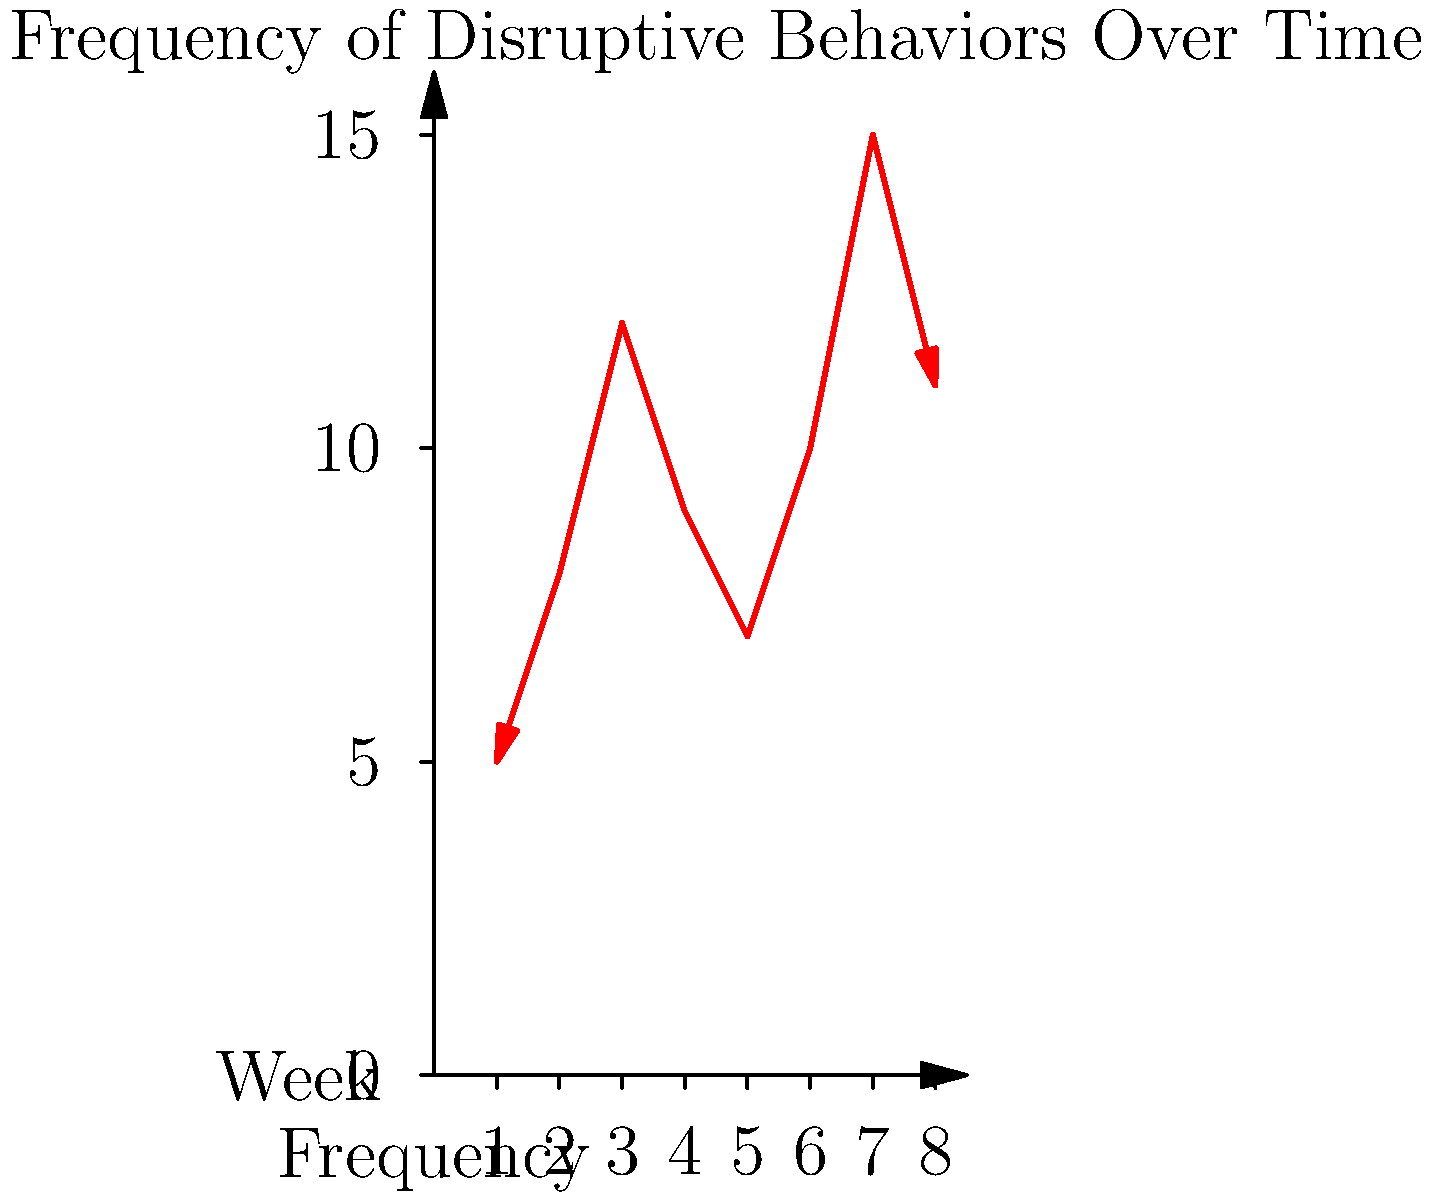Analyze the line graph showing the frequency of disruptive behaviors over an 8-week period. What trend does the data suggest, and how might this information be used to inform behavior management strategies? To analyze the graph and identify trends, we should follow these steps:

1. Observe the overall pattern:
   The line graph shows fluctuations in the frequency of disruptive behaviors over 8 weeks.

2. Identify key points:
   - Starting point: Week 1 with 5 incidents
   - Highest point: Week 7 with 15 incidents
   - Lowest point: Week 1 with 5 incidents

3. Analyze short-term trends:
   - Weeks 1-3: Increase from 5 to 12 incidents
   - Weeks 3-5: Decrease from 12 to 7 incidents
   - Weeks 5-7: Increase from 7 to 15 incidents
   - Weeks 7-8: Decrease from 15 to 11 incidents

4. Identify the overall trend:
   Despite fluctuations, there is a general upward trend in disruptive behaviors over the 8-week period.

5. Consider implications for behavior management:
   a. The overall increase suggests that current strategies may not be effective and need revision.
   b. The fluctuations indicate that external factors might be influencing behavior patterns.
   c. The peak in Week 7 may require investigation to understand what specific triggers or events occurred.

6. Propose potential strategies:
   a. Implement more intensive interventions during periods of increased disruptive behaviors.
   b. Conduct functional behavior assessments to identify triggers for the increases.
   c. Collaborate with the special education teacher to modify the classroom environment or routines during high-frequency periods.
   d. Develop personalized behavior plans that address the specific patterns observed for individual students.

In summary, the data suggests an overall increasing trend in disruptive behaviors with significant weekly fluctuations. This information can be used to inform more targeted and responsive behavior management strategies, emphasizing the need for continuous monitoring and adaptation of interventions.
Answer: Increasing trend with fluctuations; informs need for adaptive, targeted interventions and functional behavior assessments. 